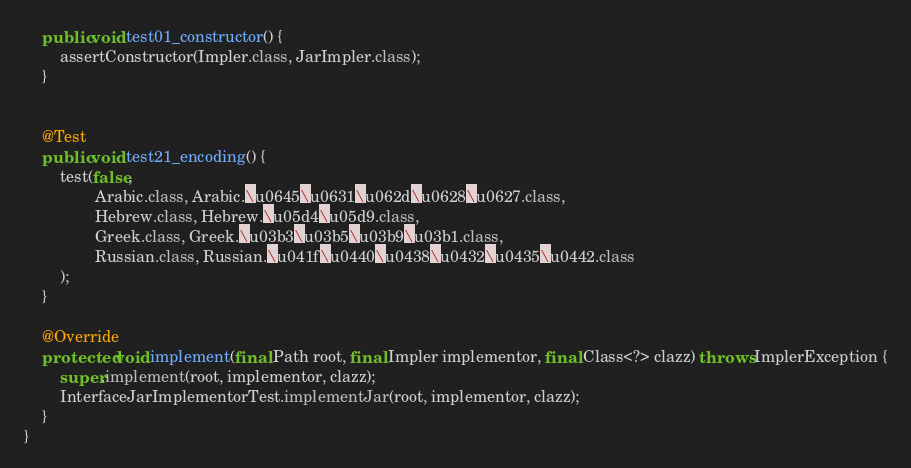<code> <loc_0><loc_0><loc_500><loc_500><_Java_>    public void test01_constructor() {
        assertConstructor(Impler.class, JarImpler.class);
    }


    @Test
    public void test21_encoding() {
        test(false,
                Arabic.class, Arabic.\u0645\u0631\u062d\u0628\u0627.class,
                Hebrew.class, Hebrew.\u05d4\u05d9.class,
                Greek.class, Greek.\u03b3\u03b5\u03b9\u03b1.class,
                Russian.class, Russian.\u041f\u0440\u0438\u0432\u0435\u0442.class
        );
    }

    @Override
    protected void implement(final Path root, final Impler implementor, final Class<?> clazz) throws ImplerException {
        super.implement(root, implementor, clazz);
        InterfaceJarImplementorTest.implementJar(root, implementor, clazz);
    }
}
</code> 